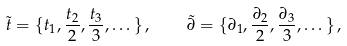Convert formula to latex. <formula><loc_0><loc_0><loc_500><loc_500>\tilde { t } = \{ t _ { 1 } , \frac { t _ { 2 } } { 2 } , \frac { t _ { 3 } } { 3 } , \dots \} \, , \quad \tilde { \partial } = \{ \partial _ { 1 } , \frac { \partial _ { 2 } } { 2 } , \frac { \partial _ { 3 } } { 3 } , \dots \} \, ,</formula> 